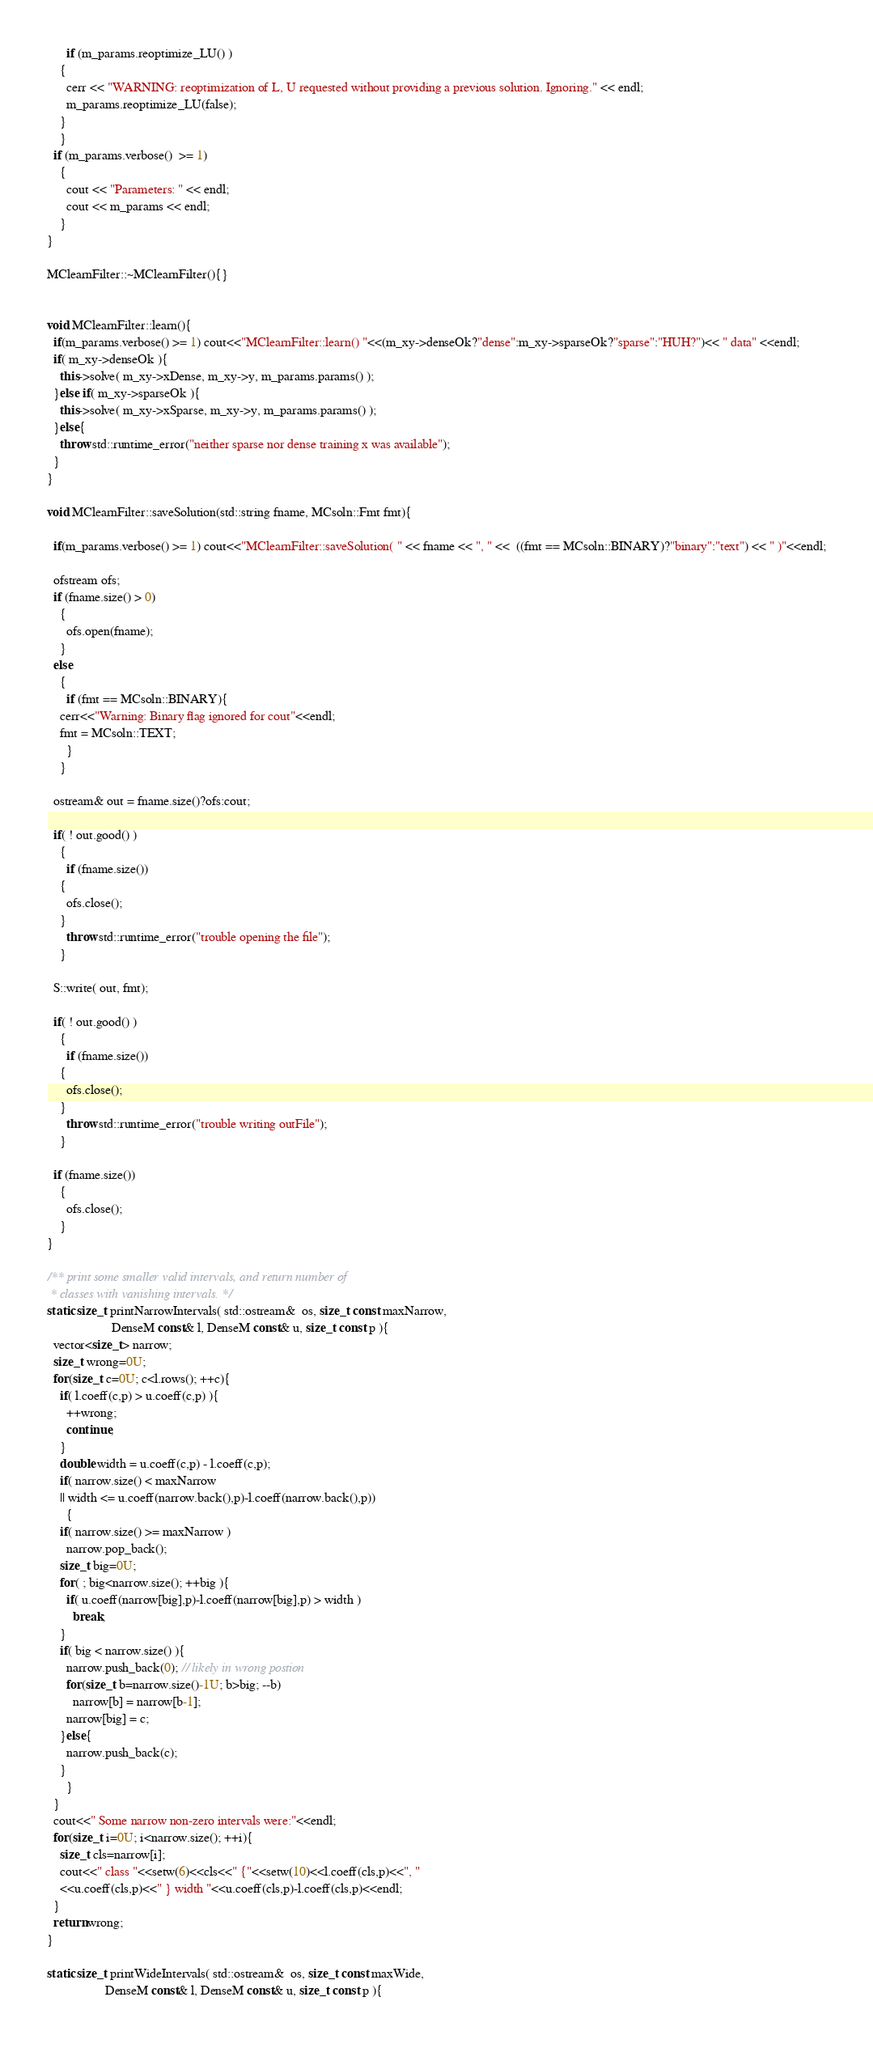<code> <loc_0><loc_0><loc_500><loc_500><_C++_>      if (m_params.reoptimize_LU() )
	{
	  cerr << "WARNING: reoptimization of L, U requested without providing a previous solution. Ignoring." << endl;
	  m_params.reoptimize_LU(false);
	}
    }
  if (m_params.verbose()  >= 1)
    {
      cout << "Parameters: " << endl;
      cout << m_params << endl;
    }
}

MClearnFilter::~MClearnFilter(){}


void MClearnFilter::learn(){
  if(m_params.verbose() >= 1) cout<<"MClearnFilter::learn() "<<(m_xy->denseOk?"dense":m_xy->sparseOk?"sparse":"HUH?")<< " data" <<endl;
  if( m_xy->denseOk ){
    this->solve( m_xy->xDense, m_xy->y, m_params.params() );
  }else if( m_xy->sparseOk ){
    this->solve( m_xy->xSparse, m_xy->y, m_params.params() );
  }else{
    throw std::runtime_error("neither sparse nor dense training x was available");
  }
}

void MClearnFilter::saveSolution(std::string fname, MCsoln::Fmt fmt){

  if(m_params.verbose() >= 1) cout<<"MClearnFilter::saveSolution( " << fname << ", " <<  ((fmt == MCsoln::BINARY)?"binary":"text") << " )"<<endl;

  ofstream ofs;
  if (fname.size() > 0)
    {
      ofs.open(fname);
    }
  else
    {
      if (fmt == MCsoln::BINARY){
	cerr<<"Warning: Binary flag ignored for cout"<<endl;
	fmt = MCsoln::TEXT;
      }
    }
    
  ostream& out = fname.size()?ofs:cout;
  
  if( ! out.good() )
    {
      if (fname.size())
	{
	  ofs.close();
	}
      throw std::runtime_error("trouble opening the file");
    }
  
  S::write( out, fmt);

  if( ! out.good() )
    {
      if (fname.size())
	{
	  ofs.close();
	}
      throw std::runtime_error("trouble writing outFile");
    }
  
  if (fname.size())
    {
      ofs.close();
    }
}
  
/** print some smaller valid intervals, and return number of
 * classes with vanishing intervals. */
static size_t printNarrowIntervals( std::ostream&  os, size_t const maxNarrow,
				    DenseM const& l, DenseM const& u, size_t const p ){
  vector<size_t> narrow;
  size_t wrong=0U;
  for(size_t c=0U; c<l.rows(); ++c){
    if( l.coeff(c,p) > u.coeff(c,p) ){
      ++wrong;
      continue;
    }
    double width = u.coeff(c,p) - l.coeff(c,p);
    if( narrow.size() < maxNarrow
	|| width <= u.coeff(narrow.back(),p)-l.coeff(narrow.back(),p))
      {
	if( narrow.size() >= maxNarrow )
	  narrow.pop_back();
	size_t big=0U;
	for( ; big<narrow.size(); ++big ){
	  if( u.coeff(narrow[big],p)-l.coeff(narrow[big],p) > width )
	    break;
	}
	if( big < narrow.size() ){
	  narrow.push_back(0); // likely in wrong postion
	  for(size_t b=narrow.size()-1U; b>big; --b)
	    narrow[b] = narrow[b-1];
	  narrow[big] = c;
	}else{
	  narrow.push_back(c);
	}
      }
  }
  cout<<" Some narrow non-zero intervals were:"<<endl;
  for(size_t i=0U; i<narrow.size(); ++i){
    size_t cls=narrow[i];
    cout<<" class "<<setw(6)<<cls<<" {"<<setw(10)<<l.coeff(cls,p)<<", "
	<<u.coeff(cls,p)<<" } width "<<u.coeff(cls,p)-l.coeff(cls,p)<<endl;
  }
  return wrong;
}

static size_t printWideIntervals( std::ostream&  os, size_t const maxWide,
				  DenseM const& l, DenseM const& u, size_t const p ){</code> 